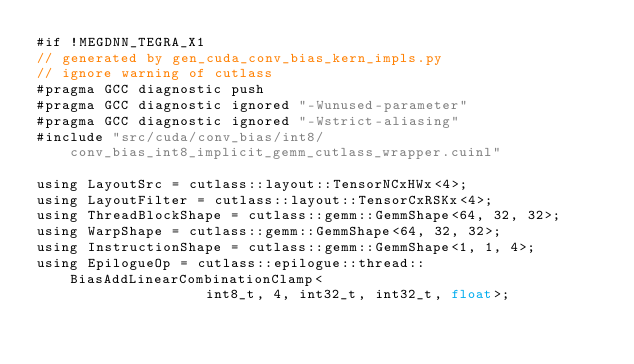<code> <loc_0><loc_0><loc_500><loc_500><_Cuda_>#if !MEGDNN_TEGRA_X1
// generated by gen_cuda_conv_bias_kern_impls.py
// ignore warning of cutlass
#pragma GCC diagnostic push
#pragma GCC diagnostic ignored "-Wunused-parameter"
#pragma GCC diagnostic ignored "-Wstrict-aliasing"
#include "src/cuda/conv_bias/int8/conv_bias_int8_implicit_gemm_cutlass_wrapper.cuinl"

using LayoutSrc = cutlass::layout::TensorNCxHWx<4>;
using LayoutFilter = cutlass::layout::TensorCxRSKx<4>;
using ThreadBlockShape = cutlass::gemm::GemmShape<64, 32, 32>;
using WarpShape = cutlass::gemm::GemmShape<64, 32, 32>;
using InstructionShape = cutlass::gemm::GemmShape<1, 1, 4>;
using EpilogueOp = cutlass::epilogue::thread::BiasAddLinearCombinationClamp<
                    int8_t, 4, int32_t, int32_t, float>;</code> 